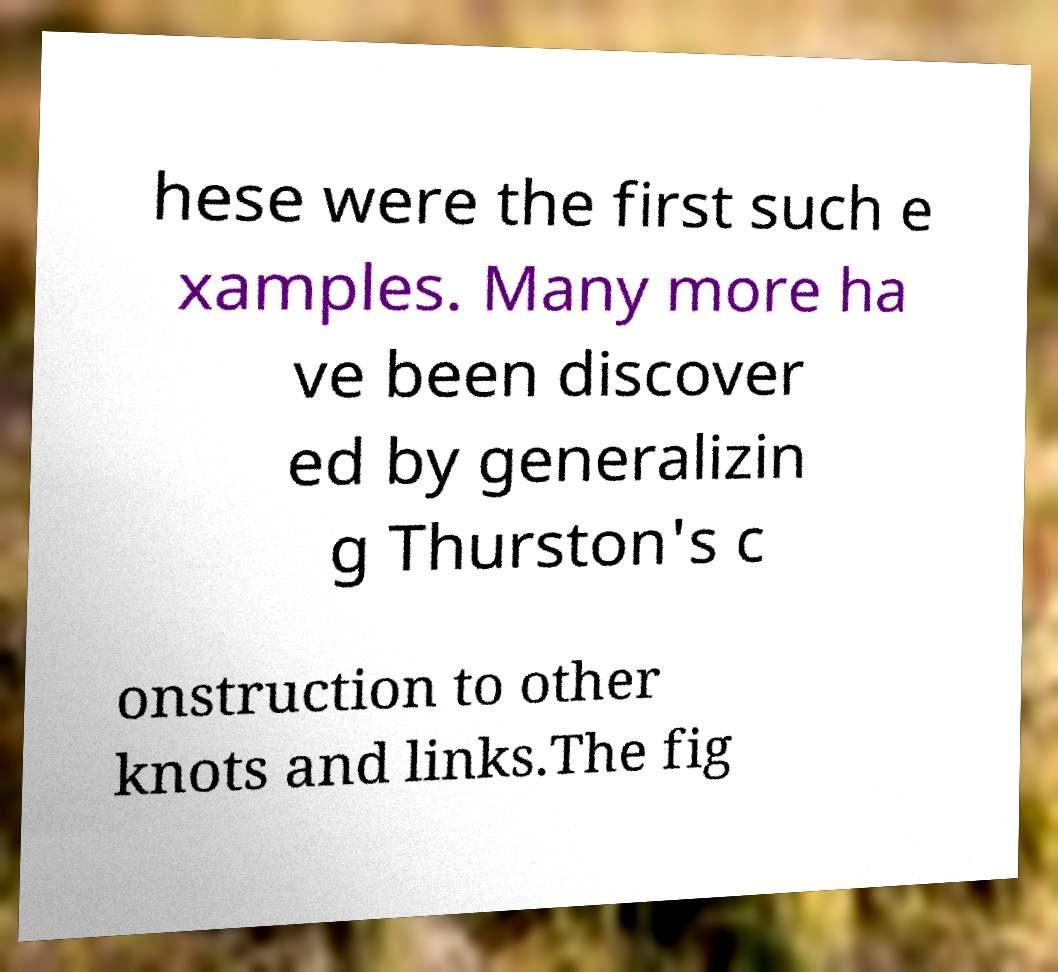There's text embedded in this image that I need extracted. Can you transcribe it verbatim? hese were the first such e xamples. Many more ha ve been discover ed by generalizin g Thurston's c onstruction to other knots and links.The fig 